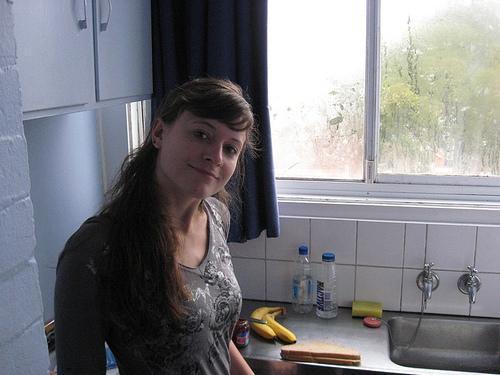How many bananas are on the counter?
Give a very brief answer. 2. How many big bear are there in the image?
Give a very brief answer. 0. 